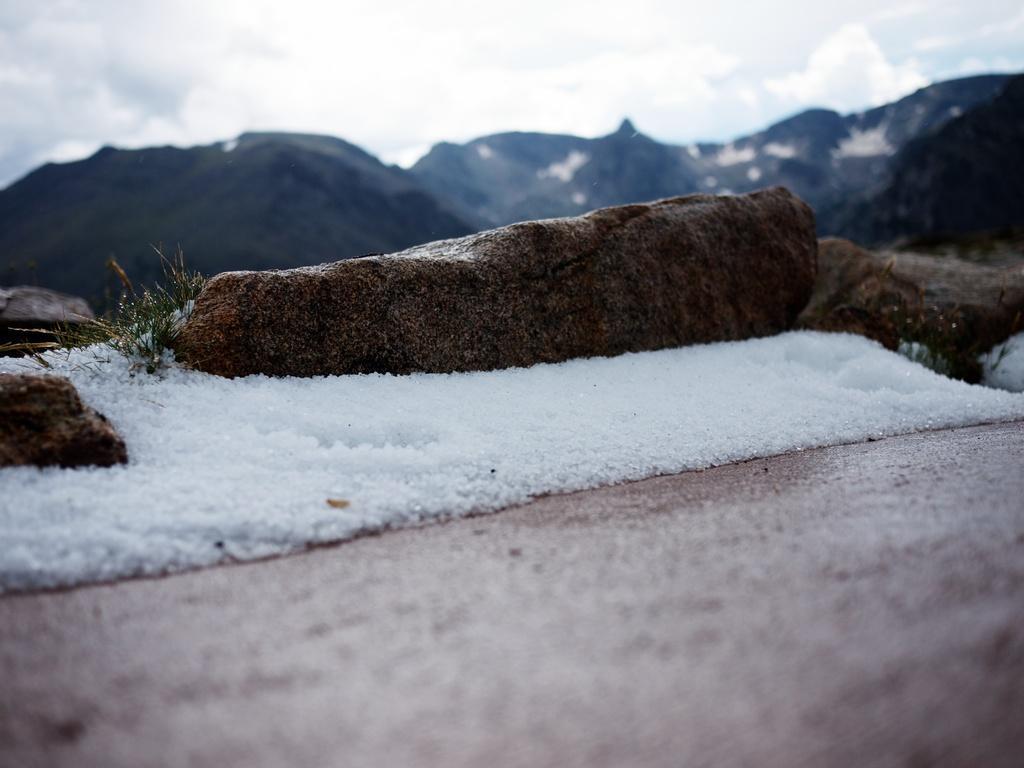Describe this image in one or two sentences. In the image there is snow and rocks, in the background there are mountains. 